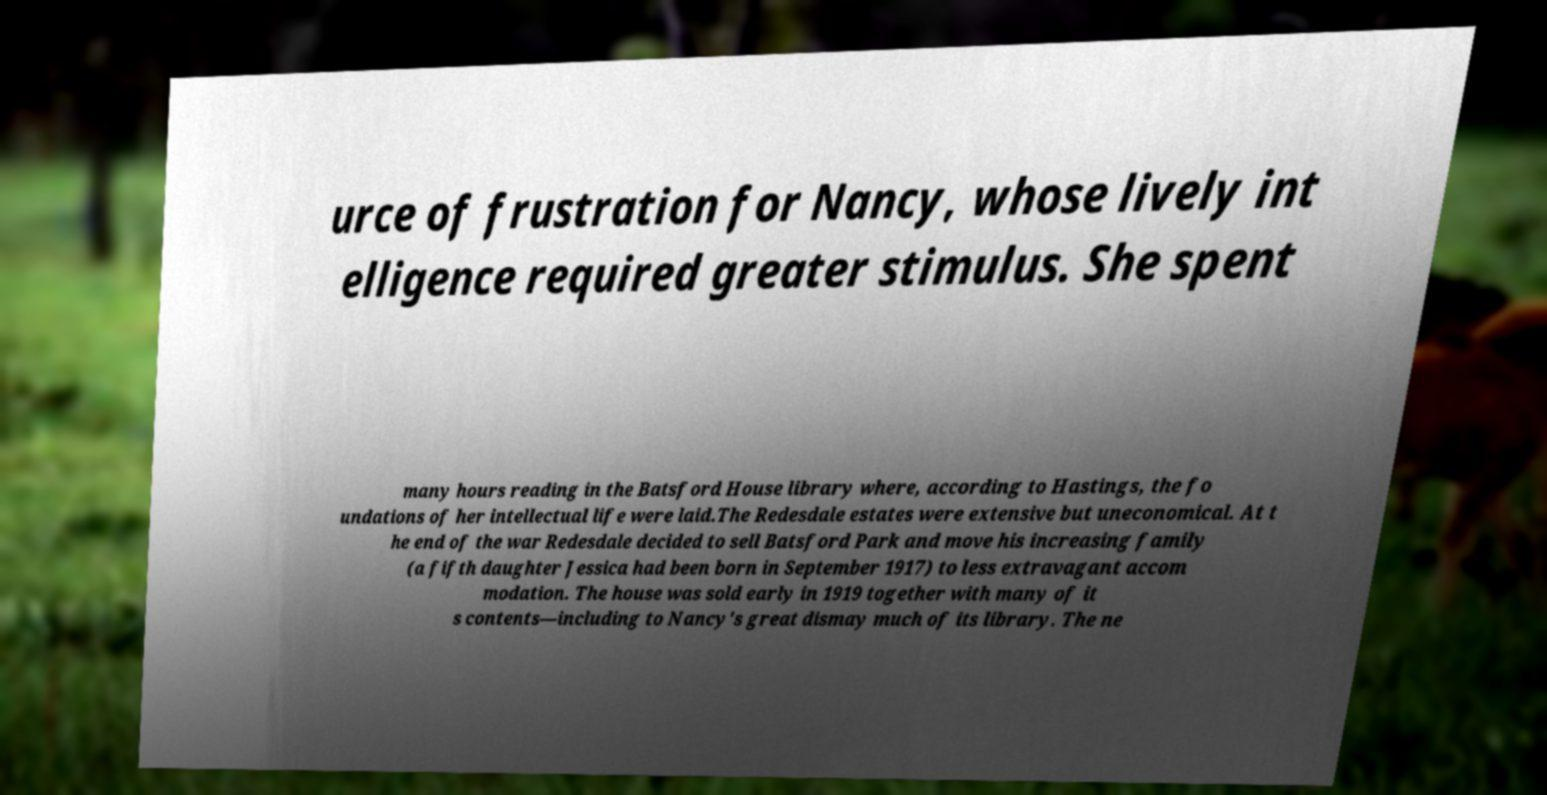Can you read and provide the text displayed in the image?This photo seems to have some interesting text. Can you extract and type it out for me? urce of frustration for Nancy, whose lively int elligence required greater stimulus. She spent many hours reading in the Batsford House library where, according to Hastings, the fo undations of her intellectual life were laid.The Redesdale estates were extensive but uneconomical. At t he end of the war Redesdale decided to sell Batsford Park and move his increasing family (a fifth daughter Jessica had been born in September 1917) to less extravagant accom modation. The house was sold early in 1919 together with many of it s contents—including to Nancy's great dismay much of its library. The ne 